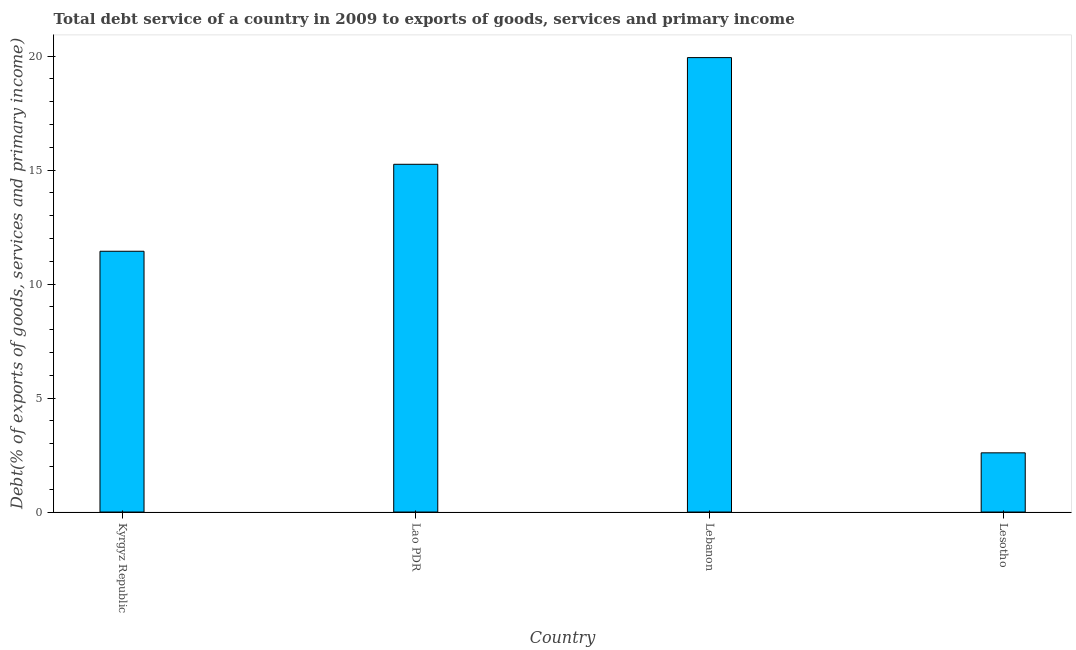Does the graph contain any zero values?
Provide a succinct answer. No. What is the title of the graph?
Provide a succinct answer. Total debt service of a country in 2009 to exports of goods, services and primary income. What is the label or title of the X-axis?
Offer a terse response. Country. What is the label or title of the Y-axis?
Offer a terse response. Debt(% of exports of goods, services and primary income). What is the total debt service in Lebanon?
Your response must be concise. 19.93. Across all countries, what is the maximum total debt service?
Offer a terse response. 19.93. Across all countries, what is the minimum total debt service?
Offer a terse response. 2.6. In which country was the total debt service maximum?
Provide a succinct answer. Lebanon. In which country was the total debt service minimum?
Offer a very short reply. Lesotho. What is the sum of the total debt service?
Keep it short and to the point. 49.22. What is the difference between the total debt service in Kyrgyz Republic and Lao PDR?
Your answer should be very brief. -3.81. What is the average total debt service per country?
Ensure brevity in your answer.  12.3. What is the median total debt service?
Your answer should be compact. 13.34. In how many countries, is the total debt service greater than 16 %?
Provide a succinct answer. 1. What is the ratio of the total debt service in Lebanon to that in Lesotho?
Your answer should be very brief. 7.68. Is the total debt service in Lao PDR less than that in Lebanon?
Keep it short and to the point. Yes. Is the difference between the total debt service in Lao PDR and Lesotho greater than the difference between any two countries?
Give a very brief answer. No. What is the difference between the highest and the second highest total debt service?
Give a very brief answer. 4.68. Is the sum of the total debt service in Lebanon and Lesotho greater than the maximum total debt service across all countries?
Offer a very short reply. Yes. What is the difference between the highest and the lowest total debt service?
Give a very brief answer. 17.33. What is the difference between two consecutive major ticks on the Y-axis?
Your answer should be compact. 5. Are the values on the major ticks of Y-axis written in scientific E-notation?
Your answer should be compact. No. What is the Debt(% of exports of goods, services and primary income) of Kyrgyz Republic?
Ensure brevity in your answer.  11.44. What is the Debt(% of exports of goods, services and primary income) of Lao PDR?
Provide a succinct answer. 15.25. What is the Debt(% of exports of goods, services and primary income) in Lebanon?
Your answer should be very brief. 19.93. What is the Debt(% of exports of goods, services and primary income) in Lesotho?
Ensure brevity in your answer.  2.6. What is the difference between the Debt(% of exports of goods, services and primary income) in Kyrgyz Republic and Lao PDR?
Provide a succinct answer. -3.81. What is the difference between the Debt(% of exports of goods, services and primary income) in Kyrgyz Republic and Lebanon?
Offer a very short reply. -8.49. What is the difference between the Debt(% of exports of goods, services and primary income) in Kyrgyz Republic and Lesotho?
Your response must be concise. 8.84. What is the difference between the Debt(% of exports of goods, services and primary income) in Lao PDR and Lebanon?
Your answer should be compact. -4.68. What is the difference between the Debt(% of exports of goods, services and primary income) in Lao PDR and Lesotho?
Keep it short and to the point. 12.66. What is the difference between the Debt(% of exports of goods, services and primary income) in Lebanon and Lesotho?
Your response must be concise. 17.33. What is the ratio of the Debt(% of exports of goods, services and primary income) in Kyrgyz Republic to that in Lao PDR?
Offer a very short reply. 0.75. What is the ratio of the Debt(% of exports of goods, services and primary income) in Kyrgyz Republic to that in Lebanon?
Provide a short and direct response. 0.57. What is the ratio of the Debt(% of exports of goods, services and primary income) in Kyrgyz Republic to that in Lesotho?
Make the answer very short. 4.41. What is the ratio of the Debt(% of exports of goods, services and primary income) in Lao PDR to that in Lebanon?
Make the answer very short. 0.77. What is the ratio of the Debt(% of exports of goods, services and primary income) in Lao PDR to that in Lesotho?
Give a very brief answer. 5.87. What is the ratio of the Debt(% of exports of goods, services and primary income) in Lebanon to that in Lesotho?
Your answer should be compact. 7.68. 